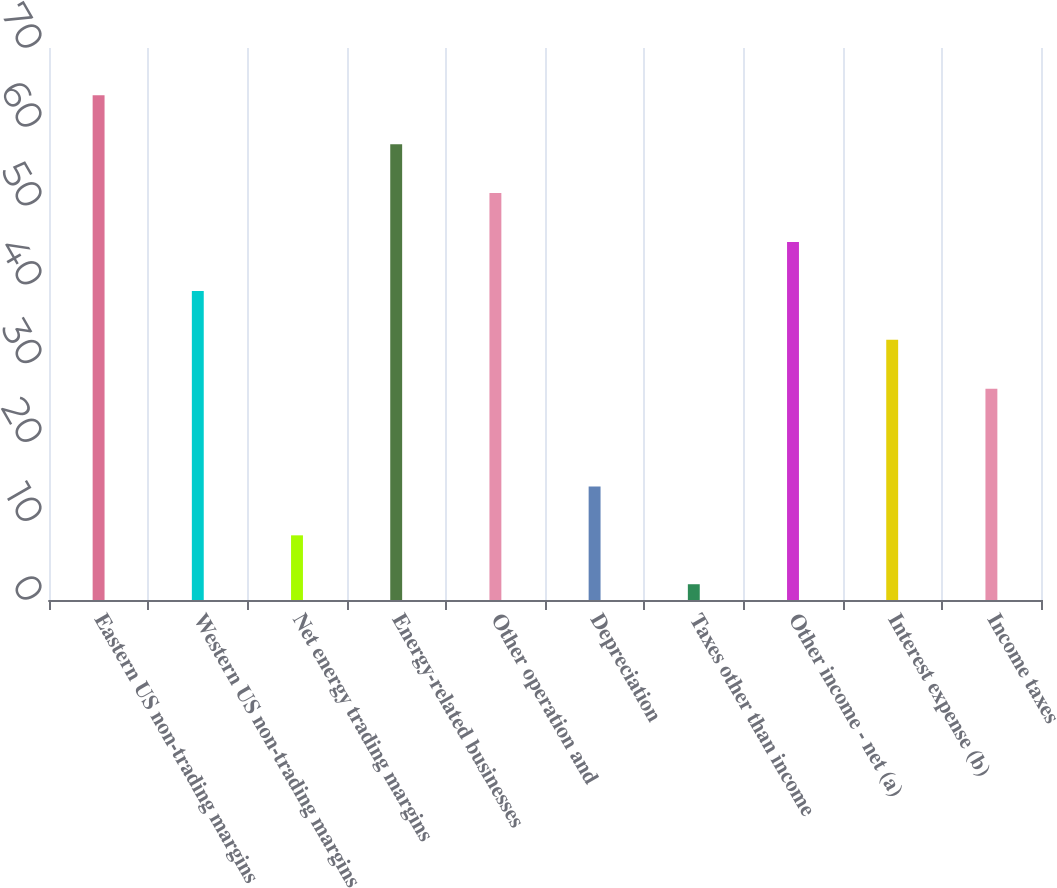<chart> <loc_0><loc_0><loc_500><loc_500><bar_chart><fcel>Eastern US non-trading margins<fcel>Western US non-trading margins<fcel>Net energy trading margins<fcel>Energy-related businesses<fcel>Other operation and<fcel>Depreciation<fcel>Taxes other than income<fcel>Other income - net (a)<fcel>Interest expense (b)<fcel>Income taxes<nl><fcel>64<fcel>39.2<fcel>8.2<fcel>57.8<fcel>51.6<fcel>14.4<fcel>2<fcel>45.4<fcel>33<fcel>26.8<nl></chart> 